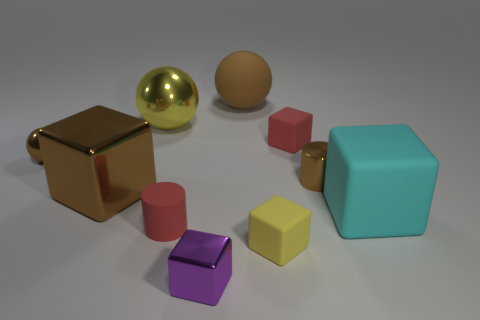Subtract all red cubes. How many brown spheres are left? 2 Subtract all brown cubes. How many cubes are left? 4 Subtract 2 cubes. How many cubes are left? 3 Subtract all tiny metallic balls. How many balls are left? 2 Subtract all cyan blocks. Subtract all gray spheres. How many blocks are left? 4 Add 8 gray rubber cylinders. How many gray rubber cylinders exist? 8 Subtract 1 purple cubes. How many objects are left? 9 Subtract all spheres. How many objects are left? 7 Subtract all large brown balls. Subtract all big rubber spheres. How many objects are left? 8 Add 1 red matte things. How many red matte things are left? 3 